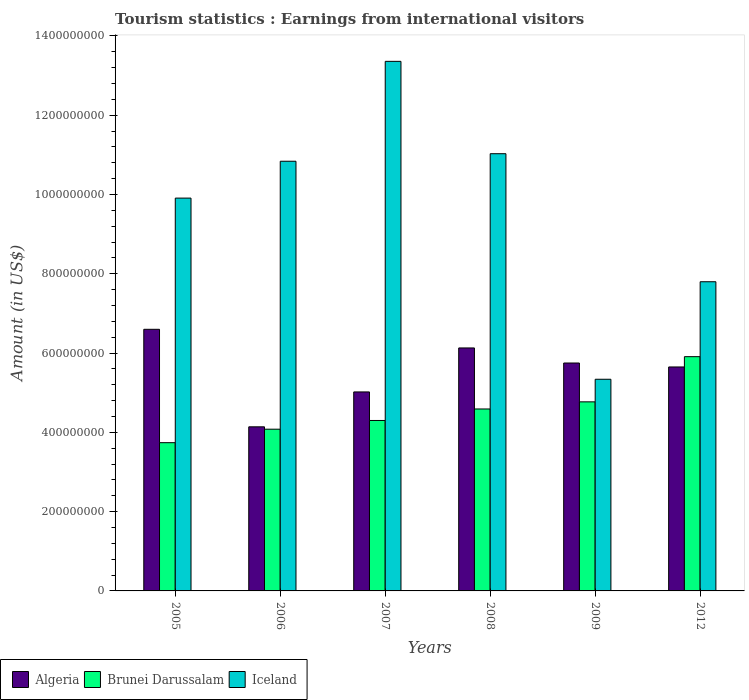How many groups of bars are there?
Your response must be concise. 6. Are the number of bars per tick equal to the number of legend labels?
Your answer should be compact. Yes. Are the number of bars on each tick of the X-axis equal?
Offer a very short reply. Yes. How many bars are there on the 3rd tick from the right?
Offer a terse response. 3. What is the label of the 5th group of bars from the left?
Offer a terse response. 2009. In how many cases, is the number of bars for a given year not equal to the number of legend labels?
Give a very brief answer. 0. What is the earnings from international visitors in Brunei Darussalam in 2007?
Your response must be concise. 4.30e+08. Across all years, what is the maximum earnings from international visitors in Algeria?
Your answer should be compact. 6.60e+08. Across all years, what is the minimum earnings from international visitors in Brunei Darussalam?
Your response must be concise. 3.74e+08. In which year was the earnings from international visitors in Algeria maximum?
Provide a short and direct response. 2005. In which year was the earnings from international visitors in Iceland minimum?
Offer a terse response. 2009. What is the total earnings from international visitors in Iceland in the graph?
Keep it short and to the point. 5.83e+09. What is the difference between the earnings from international visitors in Algeria in 2007 and that in 2012?
Make the answer very short. -6.30e+07. What is the difference between the earnings from international visitors in Brunei Darussalam in 2009 and the earnings from international visitors in Algeria in 2012?
Make the answer very short. -8.80e+07. What is the average earnings from international visitors in Iceland per year?
Give a very brief answer. 9.71e+08. In the year 2009, what is the difference between the earnings from international visitors in Iceland and earnings from international visitors in Algeria?
Your answer should be compact. -4.10e+07. What is the ratio of the earnings from international visitors in Brunei Darussalam in 2006 to that in 2009?
Give a very brief answer. 0.86. Is the earnings from international visitors in Algeria in 2005 less than that in 2008?
Offer a very short reply. No. Is the difference between the earnings from international visitors in Iceland in 2005 and 2008 greater than the difference between the earnings from international visitors in Algeria in 2005 and 2008?
Your response must be concise. No. What is the difference between the highest and the second highest earnings from international visitors in Brunei Darussalam?
Give a very brief answer. 1.14e+08. What is the difference between the highest and the lowest earnings from international visitors in Brunei Darussalam?
Offer a terse response. 2.17e+08. In how many years, is the earnings from international visitors in Iceland greater than the average earnings from international visitors in Iceland taken over all years?
Your response must be concise. 4. What does the 2nd bar from the right in 2007 represents?
Your response must be concise. Brunei Darussalam. How many bars are there?
Provide a succinct answer. 18. How many years are there in the graph?
Provide a short and direct response. 6. Are the values on the major ticks of Y-axis written in scientific E-notation?
Offer a very short reply. No. How many legend labels are there?
Your answer should be very brief. 3. How are the legend labels stacked?
Keep it short and to the point. Horizontal. What is the title of the graph?
Make the answer very short. Tourism statistics : Earnings from international visitors. Does "Zambia" appear as one of the legend labels in the graph?
Your response must be concise. No. What is the label or title of the Y-axis?
Your response must be concise. Amount (in US$). What is the Amount (in US$) of Algeria in 2005?
Keep it short and to the point. 6.60e+08. What is the Amount (in US$) of Brunei Darussalam in 2005?
Give a very brief answer. 3.74e+08. What is the Amount (in US$) of Iceland in 2005?
Offer a very short reply. 9.91e+08. What is the Amount (in US$) of Algeria in 2006?
Your response must be concise. 4.14e+08. What is the Amount (in US$) in Brunei Darussalam in 2006?
Give a very brief answer. 4.08e+08. What is the Amount (in US$) of Iceland in 2006?
Provide a short and direct response. 1.08e+09. What is the Amount (in US$) of Algeria in 2007?
Offer a terse response. 5.02e+08. What is the Amount (in US$) in Brunei Darussalam in 2007?
Give a very brief answer. 4.30e+08. What is the Amount (in US$) of Iceland in 2007?
Your response must be concise. 1.34e+09. What is the Amount (in US$) in Algeria in 2008?
Your answer should be compact. 6.13e+08. What is the Amount (in US$) of Brunei Darussalam in 2008?
Your answer should be compact. 4.59e+08. What is the Amount (in US$) of Iceland in 2008?
Your response must be concise. 1.10e+09. What is the Amount (in US$) of Algeria in 2009?
Make the answer very short. 5.75e+08. What is the Amount (in US$) of Brunei Darussalam in 2009?
Offer a terse response. 4.77e+08. What is the Amount (in US$) of Iceland in 2009?
Keep it short and to the point. 5.34e+08. What is the Amount (in US$) in Algeria in 2012?
Keep it short and to the point. 5.65e+08. What is the Amount (in US$) in Brunei Darussalam in 2012?
Your answer should be compact. 5.91e+08. What is the Amount (in US$) of Iceland in 2012?
Provide a succinct answer. 7.80e+08. Across all years, what is the maximum Amount (in US$) in Algeria?
Keep it short and to the point. 6.60e+08. Across all years, what is the maximum Amount (in US$) in Brunei Darussalam?
Provide a short and direct response. 5.91e+08. Across all years, what is the maximum Amount (in US$) in Iceland?
Keep it short and to the point. 1.34e+09. Across all years, what is the minimum Amount (in US$) of Algeria?
Your response must be concise. 4.14e+08. Across all years, what is the minimum Amount (in US$) in Brunei Darussalam?
Provide a succinct answer. 3.74e+08. Across all years, what is the minimum Amount (in US$) of Iceland?
Provide a short and direct response. 5.34e+08. What is the total Amount (in US$) of Algeria in the graph?
Offer a very short reply. 3.33e+09. What is the total Amount (in US$) in Brunei Darussalam in the graph?
Offer a terse response. 2.74e+09. What is the total Amount (in US$) of Iceland in the graph?
Give a very brief answer. 5.83e+09. What is the difference between the Amount (in US$) in Algeria in 2005 and that in 2006?
Provide a short and direct response. 2.46e+08. What is the difference between the Amount (in US$) of Brunei Darussalam in 2005 and that in 2006?
Provide a short and direct response. -3.40e+07. What is the difference between the Amount (in US$) in Iceland in 2005 and that in 2006?
Your answer should be compact. -9.30e+07. What is the difference between the Amount (in US$) in Algeria in 2005 and that in 2007?
Your response must be concise. 1.58e+08. What is the difference between the Amount (in US$) of Brunei Darussalam in 2005 and that in 2007?
Give a very brief answer. -5.60e+07. What is the difference between the Amount (in US$) in Iceland in 2005 and that in 2007?
Your response must be concise. -3.45e+08. What is the difference between the Amount (in US$) of Algeria in 2005 and that in 2008?
Offer a terse response. 4.70e+07. What is the difference between the Amount (in US$) in Brunei Darussalam in 2005 and that in 2008?
Ensure brevity in your answer.  -8.50e+07. What is the difference between the Amount (in US$) of Iceland in 2005 and that in 2008?
Your answer should be very brief. -1.12e+08. What is the difference between the Amount (in US$) of Algeria in 2005 and that in 2009?
Ensure brevity in your answer.  8.50e+07. What is the difference between the Amount (in US$) in Brunei Darussalam in 2005 and that in 2009?
Offer a terse response. -1.03e+08. What is the difference between the Amount (in US$) of Iceland in 2005 and that in 2009?
Offer a very short reply. 4.57e+08. What is the difference between the Amount (in US$) of Algeria in 2005 and that in 2012?
Your answer should be compact. 9.50e+07. What is the difference between the Amount (in US$) of Brunei Darussalam in 2005 and that in 2012?
Provide a succinct answer. -2.17e+08. What is the difference between the Amount (in US$) of Iceland in 2005 and that in 2012?
Offer a very short reply. 2.11e+08. What is the difference between the Amount (in US$) of Algeria in 2006 and that in 2007?
Your answer should be very brief. -8.80e+07. What is the difference between the Amount (in US$) of Brunei Darussalam in 2006 and that in 2007?
Your answer should be very brief. -2.20e+07. What is the difference between the Amount (in US$) in Iceland in 2006 and that in 2007?
Provide a short and direct response. -2.52e+08. What is the difference between the Amount (in US$) in Algeria in 2006 and that in 2008?
Make the answer very short. -1.99e+08. What is the difference between the Amount (in US$) of Brunei Darussalam in 2006 and that in 2008?
Your response must be concise. -5.10e+07. What is the difference between the Amount (in US$) of Iceland in 2006 and that in 2008?
Keep it short and to the point. -1.90e+07. What is the difference between the Amount (in US$) of Algeria in 2006 and that in 2009?
Provide a short and direct response. -1.61e+08. What is the difference between the Amount (in US$) in Brunei Darussalam in 2006 and that in 2009?
Your answer should be very brief. -6.90e+07. What is the difference between the Amount (in US$) of Iceland in 2006 and that in 2009?
Your response must be concise. 5.50e+08. What is the difference between the Amount (in US$) in Algeria in 2006 and that in 2012?
Give a very brief answer. -1.51e+08. What is the difference between the Amount (in US$) of Brunei Darussalam in 2006 and that in 2012?
Ensure brevity in your answer.  -1.83e+08. What is the difference between the Amount (in US$) of Iceland in 2006 and that in 2012?
Offer a very short reply. 3.04e+08. What is the difference between the Amount (in US$) in Algeria in 2007 and that in 2008?
Ensure brevity in your answer.  -1.11e+08. What is the difference between the Amount (in US$) in Brunei Darussalam in 2007 and that in 2008?
Make the answer very short. -2.90e+07. What is the difference between the Amount (in US$) in Iceland in 2007 and that in 2008?
Give a very brief answer. 2.33e+08. What is the difference between the Amount (in US$) of Algeria in 2007 and that in 2009?
Provide a succinct answer. -7.30e+07. What is the difference between the Amount (in US$) in Brunei Darussalam in 2007 and that in 2009?
Your response must be concise. -4.70e+07. What is the difference between the Amount (in US$) of Iceland in 2007 and that in 2009?
Keep it short and to the point. 8.02e+08. What is the difference between the Amount (in US$) in Algeria in 2007 and that in 2012?
Ensure brevity in your answer.  -6.30e+07. What is the difference between the Amount (in US$) in Brunei Darussalam in 2007 and that in 2012?
Ensure brevity in your answer.  -1.61e+08. What is the difference between the Amount (in US$) in Iceland in 2007 and that in 2012?
Offer a very short reply. 5.56e+08. What is the difference between the Amount (in US$) in Algeria in 2008 and that in 2009?
Your answer should be compact. 3.80e+07. What is the difference between the Amount (in US$) of Brunei Darussalam in 2008 and that in 2009?
Your response must be concise. -1.80e+07. What is the difference between the Amount (in US$) of Iceland in 2008 and that in 2009?
Your response must be concise. 5.69e+08. What is the difference between the Amount (in US$) in Algeria in 2008 and that in 2012?
Your answer should be very brief. 4.80e+07. What is the difference between the Amount (in US$) of Brunei Darussalam in 2008 and that in 2012?
Offer a very short reply. -1.32e+08. What is the difference between the Amount (in US$) in Iceland in 2008 and that in 2012?
Make the answer very short. 3.23e+08. What is the difference between the Amount (in US$) of Algeria in 2009 and that in 2012?
Provide a succinct answer. 1.00e+07. What is the difference between the Amount (in US$) of Brunei Darussalam in 2009 and that in 2012?
Your response must be concise. -1.14e+08. What is the difference between the Amount (in US$) of Iceland in 2009 and that in 2012?
Make the answer very short. -2.46e+08. What is the difference between the Amount (in US$) of Algeria in 2005 and the Amount (in US$) of Brunei Darussalam in 2006?
Your answer should be compact. 2.52e+08. What is the difference between the Amount (in US$) in Algeria in 2005 and the Amount (in US$) in Iceland in 2006?
Make the answer very short. -4.24e+08. What is the difference between the Amount (in US$) in Brunei Darussalam in 2005 and the Amount (in US$) in Iceland in 2006?
Offer a terse response. -7.10e+08. What is the difference between the Amount (in US$) of Algeria in 2005 and the Amount (in US$) of Brunei Darussalam in 2007?
Your response must be concise. 2.30e+08. What is the difference between the Amount (in US$) of Algeria in 2005 and the Amount (in US$) of Iceland in 2007?
Provide a short and direct response. -6.76e+08. What is the difference between the Amount (in US$) in Brunei Darussalam in 2005 and the Amount (in US$) in Iceland in 2007?
Offer a very short reply. -9.62e+08. What is the difference between the Amount (in US$) in Algeria in 2005 and the Amount (in US$) in Brunei Darussalam in 2008?
Ensure brevity in your answer.  2.01e+08. What is the difference between the Amount (in US$) of Algeria in 2005 and the Amount (in US$) of Iceland in 2008?
Offer a terse response. -4.43e+08. What is the difference between the Amount (in US$) of Brunei Darussalam in 2005 and the Amount (in US$) of Iceland in 2008?
Provide a succinct answer. -7.29e+08. What is the difference between the Amount (in US$) of Algeria in 2005 and the Amount (in US$) of Brunei Darussalam in 2009?
Ensure brevity in your answer.  1.83e+08. What is the difference between the Amount (in US$) in Algeria in 2005 and the Amount (in US$) in Iceland in 2009?
Your answer should be very brief. 1.26e+08. What is the difference between the Amount (in US$) of Brunei Darussalam in 2005 and the Amount (in US$) of Iceland in 2009?
Offer a terse response. -1.60e+08. What is the difference between the Amount (in US$) in Algeria in 2005 and the Amount (in US$) in Brunei Darussalam in 2012?
Provide a short and direct response. 6.90e+07. What is the difference between the Amount (in US$) in Algeria in 2005 and the Amount (in US$) in Iceland in 2012?
Ensure brevity in your answer.  -1.20e+08. What is the difference between the Amount (in US$) of Brunei Darussalam in 2005 and the Amount (in US$) of Iceland in 2012?
Make the answer very short. -4.06e+08. What is the difference between the Amount (in US$) in Algeria in 2006 and the Amount (in US$) in Brunei Darussalam in 2007?
Offer a terse response. -1.60e+07. What is the difference between the Amount (in US$) of Algeria in 2006 and the Amount (in US$) of Iceland in 2007?
Make the answer very short. -9.22e+08. What is the difference between the Amount (in US$) in Brunei Darussalam in 2006 and the Amount (in US$) in Iceland in 2007?
Give a very brief answer. -9.28e+08. What is the difference between the Amount (in US$) in Algeria in 2006 and the Amount (in US$) in Brunei Darussalam in 2008?
Keep it short and to the point. -4.50e+07. What is the difference between the Amount (in US$) in Algeria in 2006 and the Amount (in US$) in Iceland in 2008?
Make the answer very short. -6.89e+08. What is the difference between the Amount (in US$) in Brunei Darussalam in 2006 and the Amount (in US$) in Iceland in 2008?
Offer a very short reply. -6.95e+08. What is the difference between the Amount (in US$) of Algeria in 2006 and the Amount (in US$) of Brunei Darussalam in 2009?
Give a very brief answer. -6.30e+07. What is the difference between the Amount (in US$) in Algeria in 2006 and the Amount (in US$) in Iceland in 2009?
Your response must be concise. -1.20e+08. What is the difference between the Amount (in US$) of Brunei Darussalam in 2006 and the Amount (in US$) of Iceland in 2009?
Your response must be concise. -1.26e+08. What is the difference between the Amount (in US$) in Algeria in 2006 and the Amount (in US$) in Brunei Darussalam in 2012?
Keep it short and to the point. -1.77e+08. What is the difference between the Amount (in US$) in Algeria in 2006 and the Amount (in US$) in Iceland in 2012?
Your answer should be very brief. -3.66e+08. What is the difference between the Amount (in US$) in Brunei Darussalam in 2006 and the Amount (in US$) in Iceland in 2012?
Provide a succinct answer. -3.72e+08. What is the difference between the Amount (in US$) of Algeria in 2007 and the Amount (in US$) of Brunei Darussalam in 2008?
Give a very brief answer. 4.30e+07. What is the difference between the Amount (in US$) of Algeria in 2007 and the Amount (in US$) of Iceland in 2008?
Your response must be concise. -6.01e+08. What is the difference between the Amount (in US$) in Brunei Darussalam in 2007 and the Amount (in US$) in Iceland in 2008?
Offer a very short reply. -6.73e+08. What is the difference between the Amount (in US$) in Algeria in 2007 and the Amount (in US$) in Brunei Darussalam in 2009?
Your response must be concise. 2.50e+07. What is the difference between the Amount (in US$) of Algeria in 2007 and the Amount (in US$) of Iceland in 2009?
Your response must be concise. -3.20e+07. What is the difference between the Amount (in US$) in Brunei Darussalam in 2007 and the Amount (in US$) in Iceland in 2009?
Your answer should be very brief. -1.04e+08. What is the difference between the Amount (in US$) of Algeria in 2007 and the Amount (in US$) of Brunei Darussalam in 2012?
Your answer should be very brief. -8.90e+07. What is the difference between the Amount (in US$) of Algeria in 2007 and the Amount (in US$) of Iceland in 2012?
Ensure brevity in your answer.  -2.78e+08. What is the difference between the Amount (in US$) in Brunei Darussalam in 2007 and the Amount (in US$) in Iceland in 2012?
Make the answer very short. -3.50e+08. What is the difference between the Amount (in US$) of Algeria in 2008 and the Amount (in US$) of Brunei Darussalam in 2009?
Keep it short and to the point. 1.36e+08. What is the difference between the Amount (in US$) of Algeria in 2008 and the Amount (in US$) of Iceland in 2009?
Ensure brevity in your answer.  7.90e+07. What is the difference between the Amount (in US$) of Brunei Darussalam in 2008 and the Amount (in US$) of Iceland in 2009?
Your response must be concise. -7.50e+07. What is the difference between the Amount (in US$) in Algeria in 2008 and the Amount (in US$) in Brunei Darussalam in 2012?
Offer a very short reply. 2.20e+07. What is the difference between the Amount (in US$) of Algeria in 2008 and the Amount (in US$) of Iceland in 2012?
Your response must be concise. -1.67e+08. What is the difference between the Amount (in US$) of Brunei Darussalam in 2008 and the Amount (in US$) of Iceland in 2012?
Your response must be concise. -3.21e+08. What is the difference between the Amount (in US$) of Algeria in 2009 and the Amount (in US$) of Brunei Darussalam in 2012?
Make the answer very short. -1.60e+07. What is the difference between the Amount (in US$) of Algeria in 2009 and the Amount (in US$) of Iceland in 2012?
Provide a short and direct response. -2.05e+08. What is the difference between the Amount (in US$) of Brunei Darussalam in 2009 and the Amount (in US$) of Iceland in 2012?
Your answer should be very brief. -3.03e+08. What is the average Amount (in US$) in Algeria per year?
Keep it short and to the point. 5.55e+08. What is the average Amount (in US$) in Brunei Darussalam per year?
Your response must be concise. 4.56e+08. What is the average Amount (in US$) of Iceland per year?
Your response must be concise. 9.71e+08. In the year 2005, what is the difference between the Amount (in US$) in Algeria and Amount (in US$) in Brunei Darussalam?
Provide a succinct answer. 2.86e+08. In the year 2005, what is the difference between the Amount (in US$) of Algeria and Amount (in US$) of Iceland?
Your answer should be compact. -3.31e+08. In the year 2005, what is the difference between the Amount (in US$) of Brunei Darussalam and Amount (in US$) of Iceland?
Your answer should be very brief. -6.17e+08. In the year 2006, what is the difference between the Amount (in US$) of Algeria and Amount (in US$) of Brunei Darussalam?
Offer a terse response. 6.00e+06. In the year 2006, what is the difference between the Amount (in US$) of Algeria and Amount (in US$) of Iceland?
Your answer should be compact. -6.70e+08. In the year 2006, what is the difference between the Amount (in US$) in Brunei Darussalam and Amount (in US$) in Iceland?
Your response must be concise. -6.76e+08. In the year 2007, what is the difference between the Amount (in US$) in Algeria and Amount (in US$) in Brunei Darussalam?
Offer a terse response. 7.20e+07. In the year 2007, what is the difference between the Amount (in US$) in Algeria and Amount (in US$) in Iceland?
Your answer should be compact. -8.34e+08. In the year 2007, what is the difference between the Amount (in US$) in Brunei Darussalam and Amount (in US$) in Iceland?
Your answer should be very brief. -9.06e+08. In the year 2008, what is the difference between the Amount (in US$) of Algeria and Amount (in US$) of Brunei Darussalam?
Provide a short and direct response. 1.54e+08. In the year 2008, what is the difference between the Amount (in US$) in Algeria and Amount (in US$) in Iceland?
Give a very brief answer. -4.90e+08. In the year 2008, what is the difference between the Amount (in US$) in Brunei Darussalam and Amount (in US$) in Iceland?
Your response must be concise. -6.44e+08. In the year 2009, what is the difference between the Amount (in US$) of Algeria and Amount (in US$) of Brunei Darussalam?
Your answer should be very brief. 9.80e+07. In the year 2009, what is the difference between the Amount (in US$) in Algeria and Amount (in US$) in Iceland?
Make the answer very short. 4.10e+07. In the year 2009, what is the difference between the Amount (in US$) of Brunei Darussalam and Amount (in US$) of Iceland?
Keep it short and to the point. -5.70e+07. In the year 2012, what is the difference between the Amount (in US$) of Algeria and Amount (in US$) of Brunei Darussalam?
Make the answer very short. -2.60e+07. In the year 2012, what is the difference between the Amount (in US$) of Algeria and Amount (in US$) of Iceland?
Ensure brevity in your answer.  -2.15e+08. In the year 2012, what is the difference between the Amount (in US$) of Brunei Darussalam and Amount (in US$) of Iceland?
Your response must be concise. -1.89e+08. What is the ratio of the Amount (in US$) in Algeria in 2005 to that in 2006?
Offer a terse response. 1.59. What is the ratio of the Amount (in US$) in Iceland in 2005 to that in 2006?
Make the answer very short. 0.91. What is the ratio of the Amount (in US$) in Algeria in 2005 to that in 2007?
Make the answer very short. 1.31. What is the ratio of the Amount (in US$) of Brunei Darussalam in 2005 to that in 2007?
Make the answer very short. 0.87. What is the ratio of the Amount (in US$) in Iceland in 2005 to that in 2007?
Give a very brief answer. 0.74. What is the ratio of the Amount (in US$) in Algeria in 2005 to that in 2008?
Provide a short and direct response. 1.08. What is the ratio of the Amount (in US$) of Brunei Darussalam in 2005 to that in 2008?
Provide a short and direct response. 0.81. What is the ratio of the Amount (in US$) of Iceland in 2005 to that in 2008?
Your answer should be very brief. 0.9. What is the ratio of the Amount (in US$) of Algeria in 2005 to that in 2009?
Your answer should be very brief. 1.15. What is the ratio of the Amount (in US$) in Brunei Darussalam in 2005 to that in 2009?
Your answer should be very brief. 0.78. What is the ratio of the Amount (in US$) in Iceland in 2005 to that in 2009?
Provide a short and direct response. 1.86. What is the ratio of the Amount (in US$) in Algeria in 2005 to that in 2012?
Your answer should be very brief. 1.17. What is the ratio of the Amount (in US$) of Brunei Darussalam in 2005 to that in 2012?
Offer a very short reply. 0.63. What is the ratio of the Amount (in US$) of Iceland in 2005 to that in 2012?
Make the answer very short. 1.27. What is the ratio of the Amount (in US$) of Algeria in 2006 to that in 2007?
Provide a short and direct response. 0.82. What is the ratio of the Amount (in US$) of Brunei Darussalam in 2006 to that in 2007?
Give a very brief answer. 0.95. What is the ratio of the Amount (in US$) of Iceland in 2006 to that in 2007?
Your response must be concise. 0.81. What is the ratio of the Amount (in US$) of Algeria in 2006 to that in 2008?
Keep it short and to the point. 0.68. What is the ratio of the Amount (in US$) of Iceland in 2006 to that in 2008?
Your response must be concise. 0.98. What is the ratio of the Amount (in US$) of Algeria in 2006 to that in 2009?
Offer a terse response. 0.72. What is the ratio of the Amount (in US$) in Brunei Darussalam in 2006 to that in 2009?
Your answer should be very brief. 0.86. What is the ratio of the Amount (in US$) in Iceland in 2006 to that in 2009?
Your answer should be very brief. 2.03. What is the ratio of the Amount (in US$) in Algeria in 2006 to that in 2012?
Ensure brevity in your answer.  0.73. What is the ratio of the Amount (in US$) of Brunei Darussalam in 2006 to that in 2012?
Offer a terse response. 0.69. What is the ratio of the Amount (in US$) of Iceland in 2006 to that in 2012?
Your answer should be very brief. 1.39. What is the ratio of the Amount (in US$) in Algeria in 2007 to that in 2008?
Make the answer very short. 0.82. What is the ratio of the Amount (in US$) of Brunei Darussalam in 2007 to that in 2008?
Ensure brevity in your answer.  0.94. What is the ratio of the Amount (in US$) in Iceland in 2007 to that in 2008?
Offer a very short reply. 1.21. What is the ratio of the Amount (in US$) in Algeria in 2007 to that in 2009?
Offer a terse response. 0.87. What is the ratio of the Amount (in US$) of Brunei Darussalam in 2007 to that in 2009?
Give a very brief answer. 0.9. What is the ratio of the Amount (in US$) in Iceland in 2007 to that in 2009?
Give a very brief answer. 2.5. What is the ratio of the Amount (in US$) of Algeria in 2007 to that in 2012?
Make the answer very short. 0.89. What is the ratio of the Amount (in US$) of Brunei Darussalam in 2007 to that in 2012?
Keep it short and to the point. 0.73. What is the ratio of the Amount (in US$) of Iceland in 2007 to that in 2012?
Make the answer very short. 1.71. What is the ratio of the Amount (in US$) in Algeria in 2008 to that in 2009?
Provide a short and direct response. 1.07. What is the ratio of the Amount (in US$) in Brunei Darussalam in 2008 to that in 2009?
Give a very brief answer. 0.96. What is the ratio of the Amount (in US$) in Iceland in 2008 to that in 2009?
Ensure brevity in your answer.  2.07. What is the ratio of the Amount (in US$) of Algeria in 2008 to that in 2012?
Offer a very short reply. 1.08. What is the ratio of the Amount (in US$) in Brunei Darussalam in 2008 to that in 2012?
Ensure brevity in your answer.  0.78. What is the ratio of the Amount (in US$) in Iceland in 2008 to that in 2012?
Ensure brevity in your answer.  1.41. What is the ratio of the Amount (in US$) in Algeria in 2009 to that in 2012?
Provide a short and direct response. 1.02. What is the ratio of the Amount (in US$) in Brunei Darussalam in 2009 to that in 2012?
Offer a terse response. 0.81. What is the ratio of the Amount (in US$) of Iceland in 2009 to that in 2012?
Ensure brevity in your answer.  0.68. What is the difference between the highest and the second highest Amount (in US$) in Algeria?
Offer a very short reply. 4.70e+07. What is the difference between the highest and the second highest Amount (in US$) of Brunei Darussalam?
Offer a very short reply. 1.14e+08. What is the difference between the highest and the second highest Amount (in US$) in Iceland?
Your answer should be very brief. 2.33e+08. What is the difference between the highest and the lowest Amount (in US$) in Algeria?
Your answer should be very brief. 2.46e+08. What is the difference between the highest and the lowest Amount (in US$) in Brunei Darussalam?
Ensure brevity in your answer.  2.17e+08. What is the difference between the highest and the lowest Amount (in US$) of Iceland?
Offer a very short reply. 8.02e+08. 